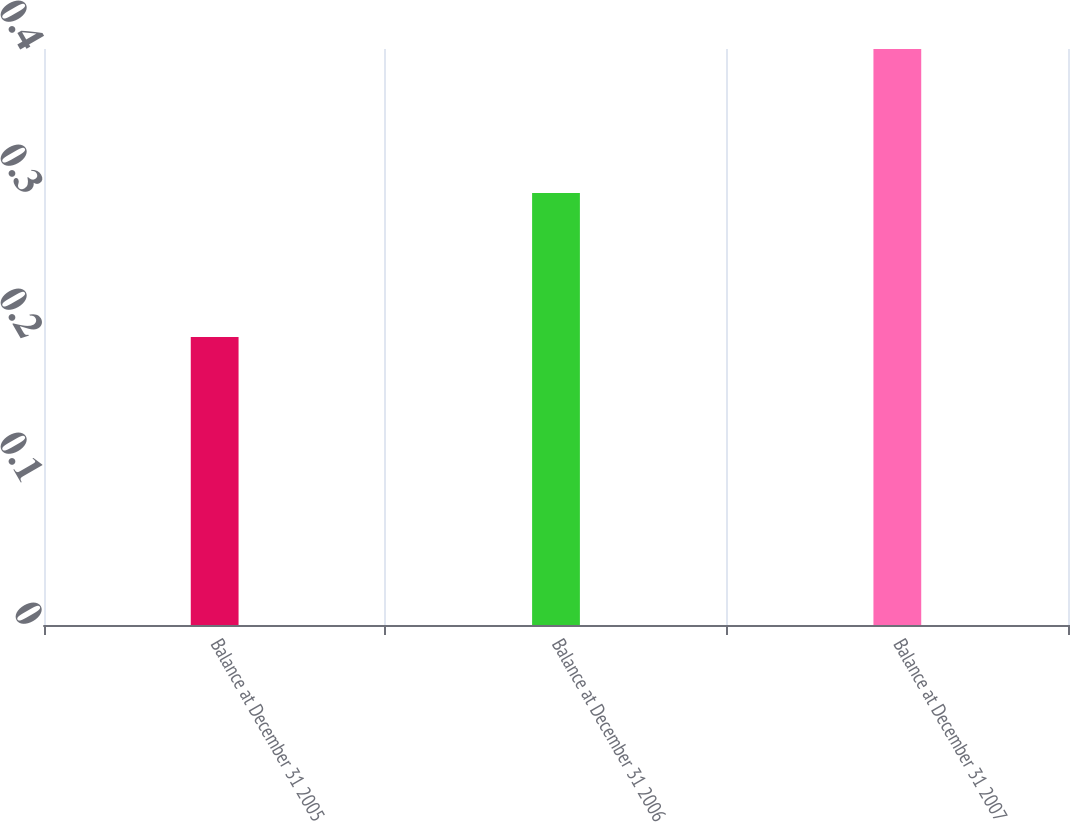Convert chart. <chart><loc_0><loc_0><loc_500><loc_500><bar_chart><fcel>Balance at December 31 2005<fcel>Balance at December 31 2006<fcel>Balance at December 31 2007<nl><fcel>0.2<fcel>0.3<fcel>0.4<nl></chart> 